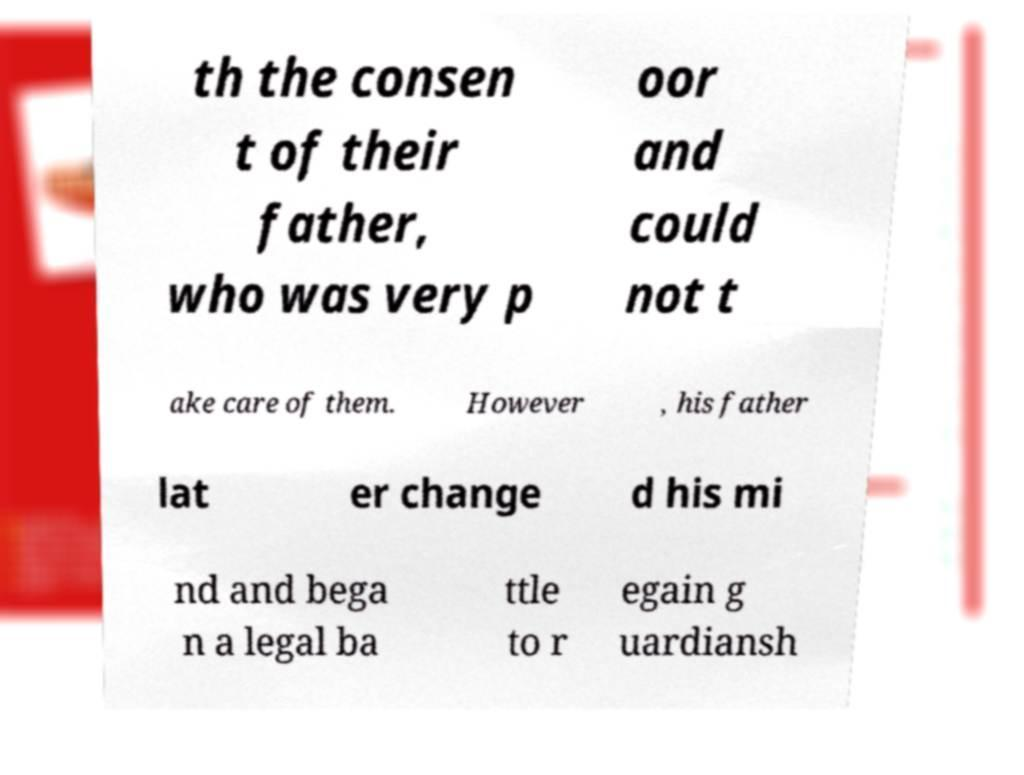Can you accurately transcribe the text from the provided image for me? th the consen t of their father, who was very p oor and could not t ake care of them. However , his father lat er change d his mi nd and bega n a legal ba ttle to r egain g uardiansh 